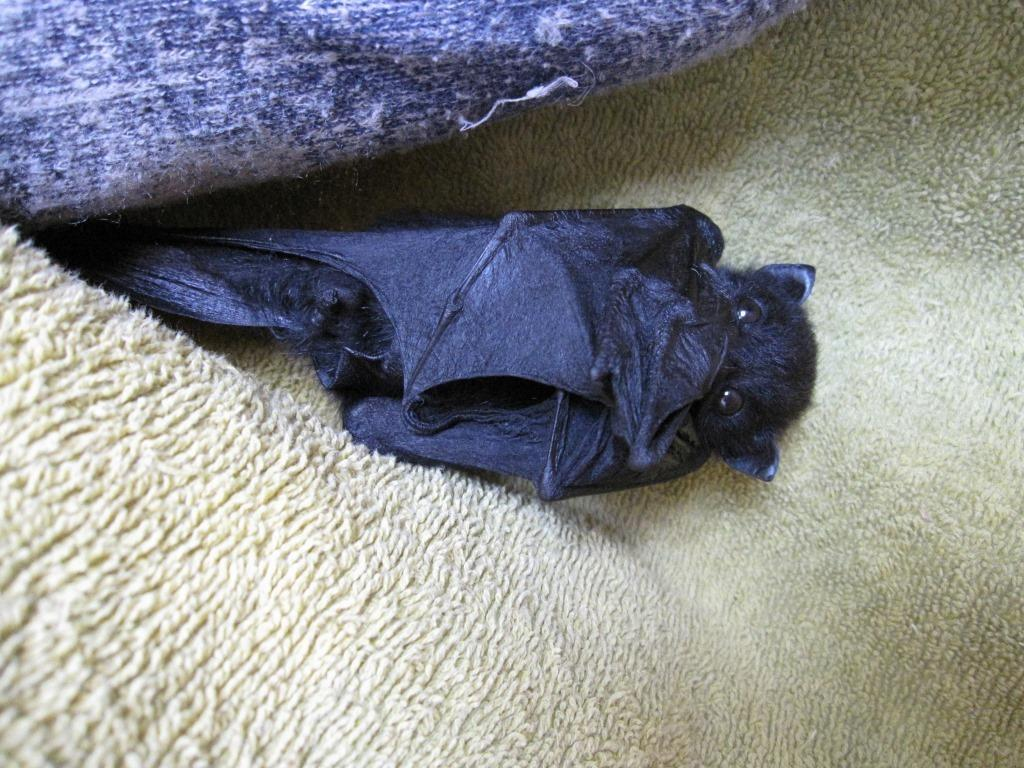What animal is present in the image? There is a bat in the image. What is the color of the bat? The bat is black in color. What is located at the bottom of the image? There is a towel at the bottom of the image. What is located at the top of the image? There is a blanket at the top of the image. How does the goose contribute to the development of the bat in the image? There is no goose present in the image, and therefore it cannot contribute to the development of the bat. 